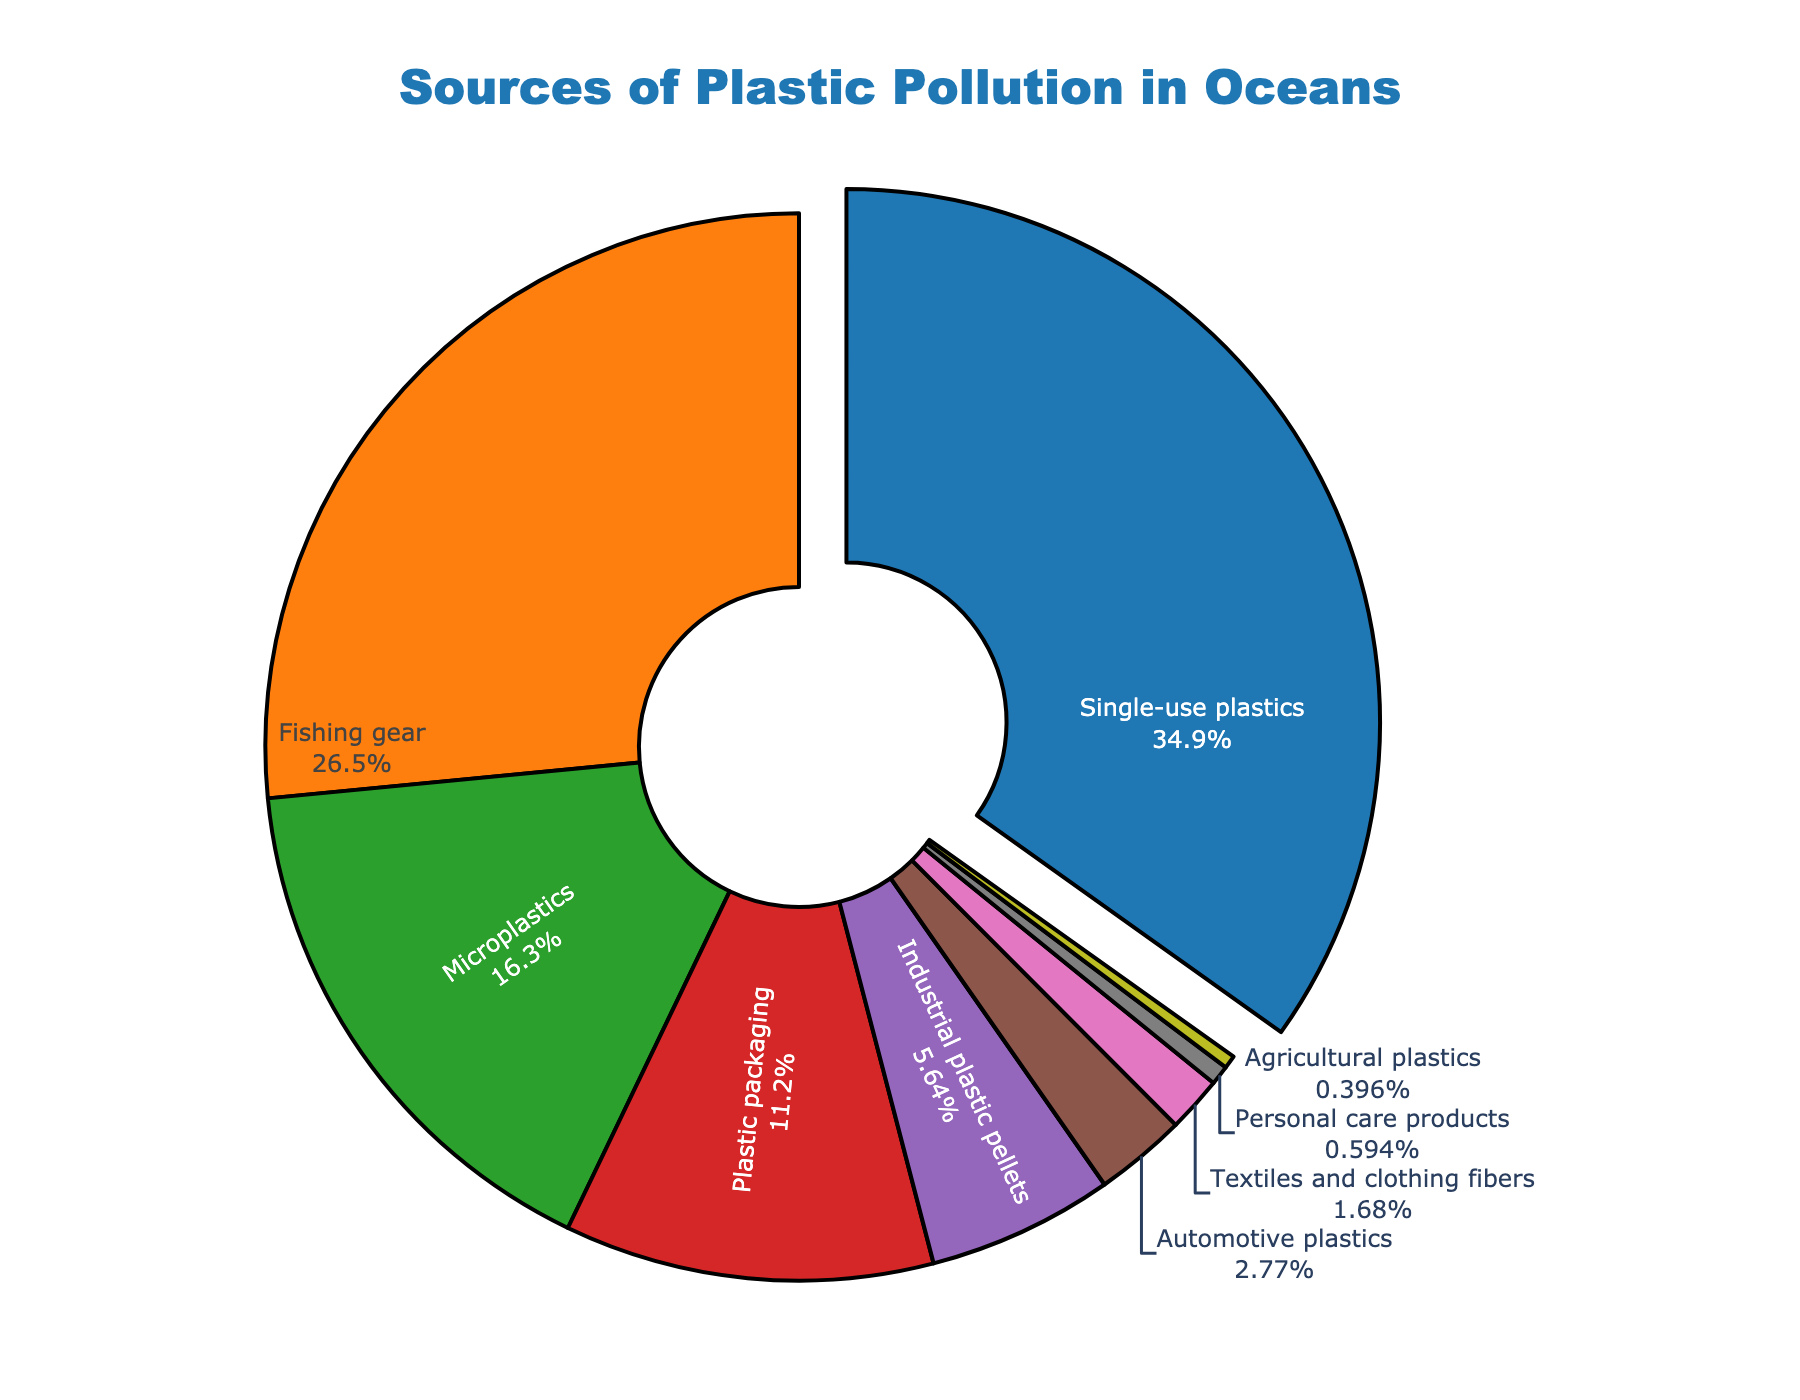What's the primary source of plastic pollution in the ocean? By looking at the pie chart, the source with the largest percentage is indicated as the primary source. The label for this segment is 'Single-use plastics', which also has the largest percentage value at 35.2%.
Answer: Single-use plastics What's the combined percentage of 'Single-use plastics' and 'Fishing gear'? The percentages for 'Single-use plastics' and 'Fishing gear' are 35.2% and 26.8% respectively. Adding these two values together gives the combined percentage: 35.2 + 26.8 = 62.0%.
Answer: 62.0% Which source contributes less than 1% to plastic pollution? The label with a segment less than 1% in the pie chart is 'Personal care products' at 0.6%, and 'Agricultural plastics' at 0.4%.
Answer: Personal care products, Agricultural plastics How does the percentage of 'Microplastics' compare to 'Industrial plastic pellets'? The percentage for 'Microplastics' is 16.5% while for 'Industrial plastic pellets' it is 5.7%. Microplastics have a higher percentage than Industrial plastic pellets, with a difference of 16.5 - 5.7 = 10.8%.
Answer: Microplastics have a higher percentage by 10.8% What is the percentage difference between 'Plastic packaging' and 'Automotive plastics'? 'Plastic packaging' has a percentage of 11.3% while 'Automotive plastics' have 2.8%. The difference is calculated as 11.3 - 2.8 = 8.5%.
Answer: 8.5% Which sources contribute more than 10% each to the total plastic pollution? From the pie chart, the sources which have percentages greater than 10% are 'Single-use plastics' at 35.2%, 'Fishing gear' at 26.8%, and 'Microplastics' at 16.5%.
Answer: Single-use plastics, Fishing gear, Microplastics What is the smallest segment in the pie chart? The segment which represents the least percentage in the pie chart is 'Agricultural plastics' at 0.4%.
Answer: Agricultural plastics Between 'Textiles and clothing fibers' and 'Personal care products', which one is a smaller contributor to plastic pollution? Comparing the percentages, 'Textiles and clothing fibers' have 1.7% while 'Personal care products' have 0.6%. 'Personal care products' is smaller.
Answer: Personal care products How much more does 'Single-use plastics' contribute compared to 'Plastic packaging'? 'Single-use plastics' contribute 35.2% while 'Plastic packaging' contributes 11.3%. The difference is 35.2 - 11.3 = 23.9%.
Answer: 23.9% 